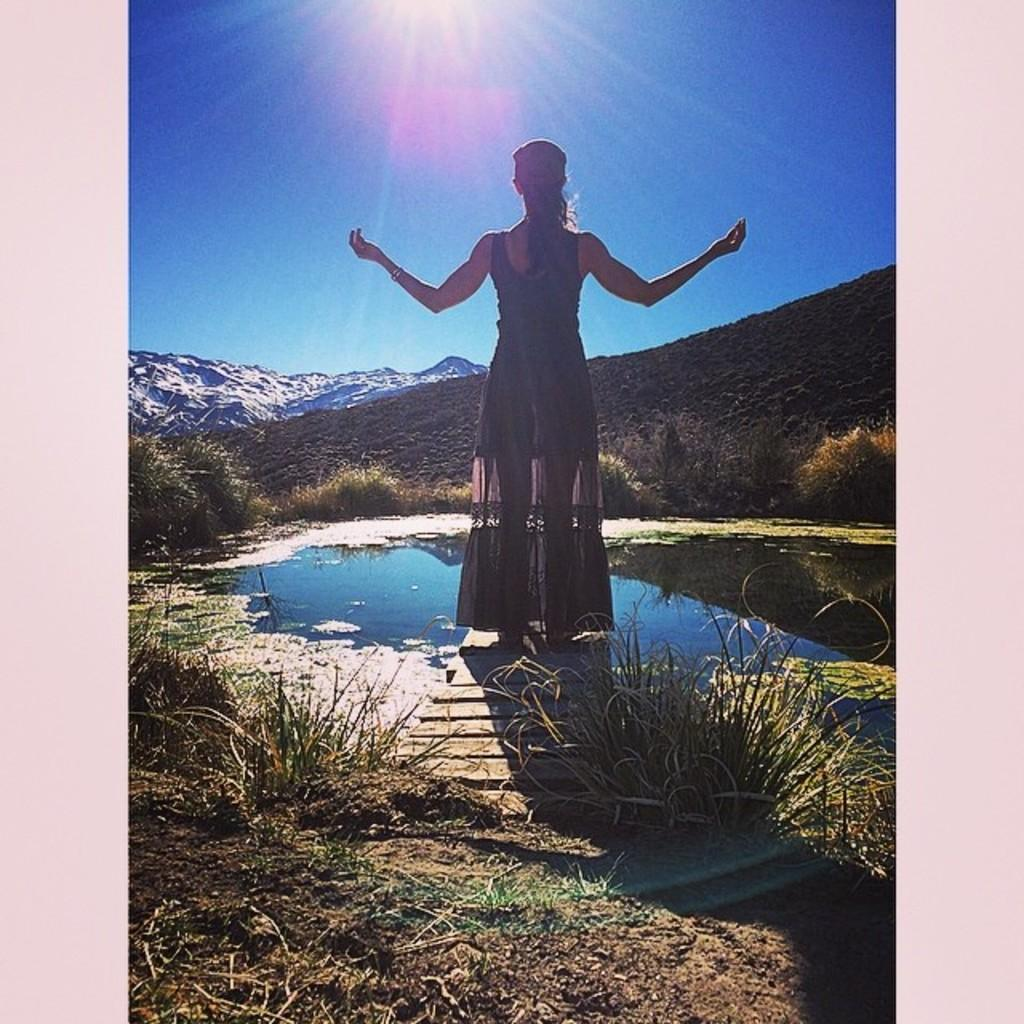What is the lady in the image standing on? The lady is standing on a wooden deck. What can be seen in the image besides the lady and the wooden deck? There is water, grass, mountains in the background, and the sky visible in the image. What type of terrain is visible in the image? The terrain includes grass and mountains. What is the condition of the sky in the image? The sky is visible in the image. How does the lady's digestion process appear in the image? There is no indication of the lady's digestion process in the image. What type of lock can be seen securing the branch in the image? There is no lock or branch present in the image. 